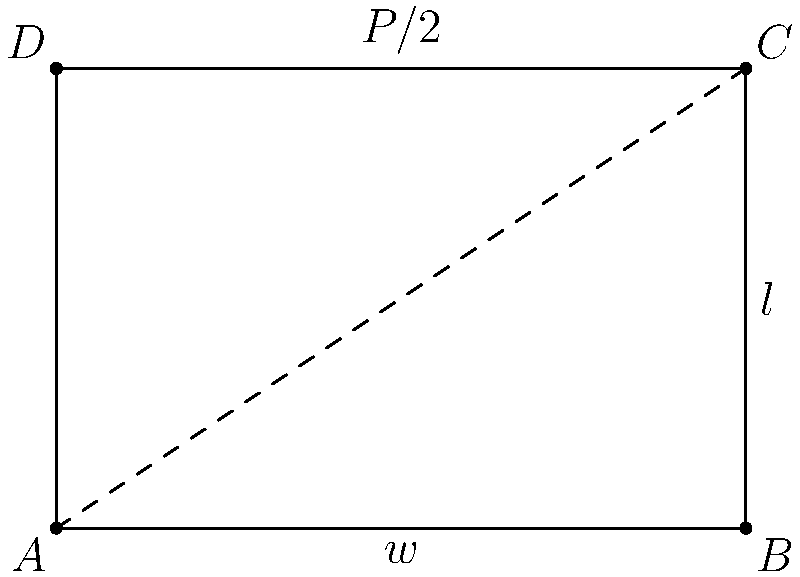As a BBQ enthusiast, you're designing a rectangular grill with a fixed perimeter $P$. Let $w$ be the width and $l$ be the length of the grill. Express the surface area $A$ of the grill in terms of $w$, and find the dimensions that will maximize the cooking surface. What is the optimal ratio of width to length for the grill? Let's approach this step-by-step:

1) The perimeter $P$ of the rectangle is given by:
   $$P = 2w + 2l$$

2) We can express $l$ in terms of $w$:
   $$l = \frac{P}{2} - w$$

3) The area $A$ of the rectangle is:
   $$A = w \cdot l = w(\frac{P}{2} - w) = \frac{P}{2}w - w^2$$

4) To find the maximum, we differentiate $A$ with respect to $w$ and set it to zero:
   $$\frac{dA}{dw} = \frac{P}{2} - 2w = 0$$

5) Solving this equation:
   $$\frac{P}{2} - 2w = 0$$
   $$\frac{P}{2} = 2w$$
   $$w = \frac{P}{4}$$

6) Since $w = \frac{P}{4}$, and $P = 2w + 2l$, we can find $l$:
   $$P = 2(\frac{P}{4}) + 2l$$
   $$P = \frac{P}{2} + 2l$$
   $$\frac{P}{2} = 2l$$
   $$l = \frac{P}{4}$$

7) We see that $w = l = \frac{P}{4}$, which means the optimal shape is a square.

8) The ratio of width to length is therefore 1:1.
Answer: 1:1 